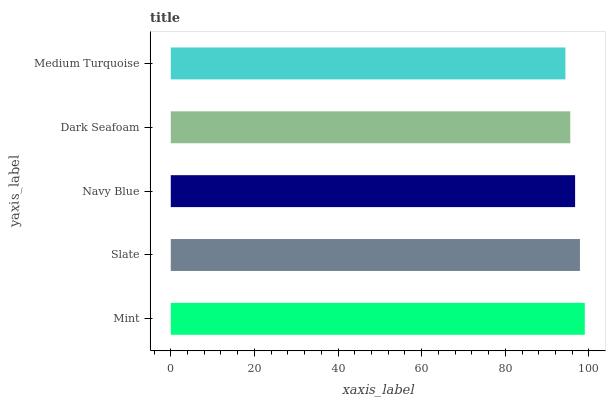Is Medium Turquoise the minimum?
Answer yes or no. Yes. Is Mint the maximum?
Answer yes or no. Yes. Is Slate the minimum?
Answer yes or no. No. Is Slate the maximum?
Answer yes or no. No. Is Mint greater than Slate?
Answer yes or no. Yes. Is Slate less than Mint?
Answer yes or no. Yes. Is Slate greater than Mint?
Answer yes or no. No. Is Mint less than Slate?
Answer yes or no. No. Is Navy Blue the high median?
Answer yes or no. Yes. Is Navy Blue the low median?
Answer yes or no. Yes. Is Slate the high median?
Answer yes or no. No. Is Slate the low median?
Answer yes or no. No. 